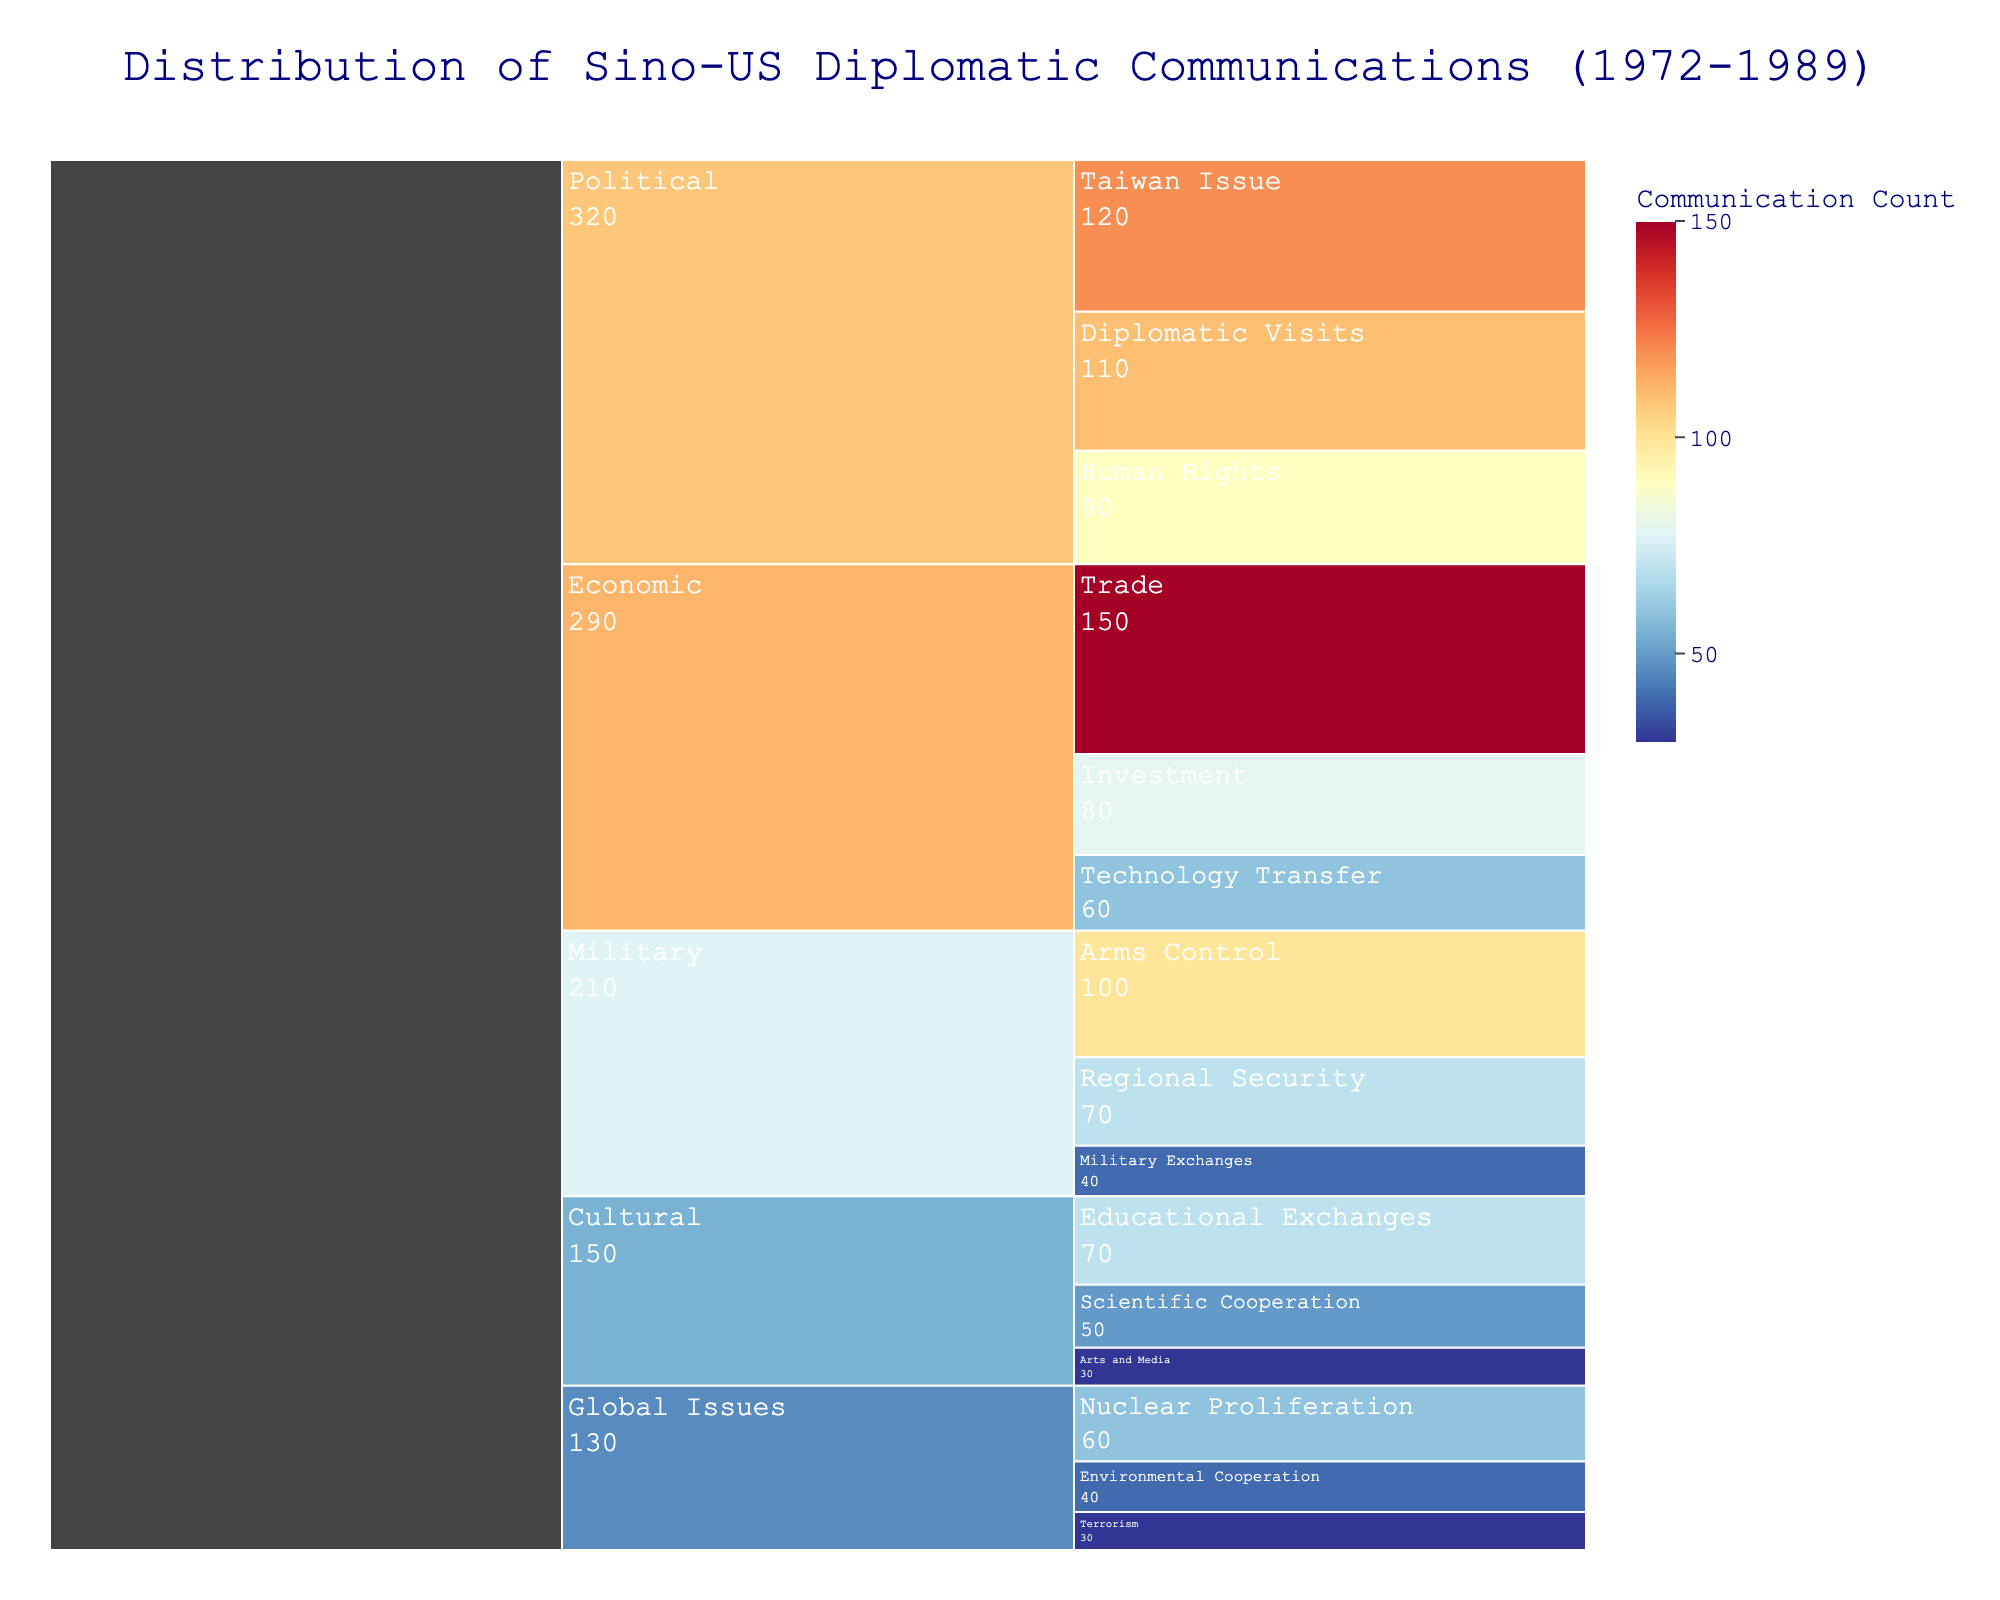What's the title of the chart? The title of a chart is typically located at the top and provides a description of the content. Here, the title is shown as "Distribution of Sino-US Diplomatic Communications (1972-1989)"
Answer: Distribution of Sino-US Diplomatic Communications (1972-1989) Which subtopic has the highest communication count within the 'Political' topic? To find this, identify the subtopics under 'Political' and check their counts. The subtopics are 'Human Rights', 'Taiwan Issue', and 'Diplomatic Visits' with counts 90, 120, and 110 respectively. 'Taiwan Issue' has the highest count of 120.
Answer: Taiwan Issue How many topics are represented in the chart? Topics are the top-level categories in the chart. They are 'Economic', 'Military', 'Political', 'Cultural', and 'Global Issues', making a total of five topics.
Answer: 5 Which topic has the least total count of diplomatic communications? Sum the counts for each topic: Economic (150+80+60=290), Military (100+70+40=210), Political (90+120+110=320), Cultural (70+50+30=150), Global Issues (40+30+60=130). 'Global Issues' has the least total count of 130.
Answer: Global Issues Compare the total count of 'Trade' and 'Taiwan Issue'. Which one is greater? 'Trade' has a count of 150, and 'Taiwan Issue' has a count of 120. Comparing these, 'Trade' has a greater count.
Answer: Trade is greater What is the combined communication count for 'Arms Control' and 'Regional Security' subtopics in the Military category? Sum the counts for 'Arms Control' and 'Regional Security': 100 + 70 = 170.
Answer: 170 How many subtopics are there under the 'Cultural' topic? The subtopics under 'Cultural' are 'Educational Exchanges', 'Scientific Cooperation', and 'Arts and Media'. This makes three subtopics.
Answer: 3 What is the average communication count of subtopics under the 'Global Issues' topic? Calculate the average by summing the counts and dividing by the number of subtopics: (40 + 30 + 60) / 3 = 130 / 3 = approximately 43.33
Answer: ~43.33 Which subtopic has the lowest communication count within the 'Cultural' topic? The subtopics under 'Cultural' are 'Educational Exchanges', 'Scientific Cooperation', and 'Arts and Media' with counts 70, 50, and 30 respectively. 'Arts and Media' has the lowest count of 30.
Answer: Arts and Media What percentage of the total communications is related to the 'Technology Transfer' subtopic? First, find the total count of all subtopics: 150+80+60+100+70+40+90+120+110+70+50+30+40+30+60 = 1100. Then, calculate the percentage: (60 / 1100) * 100 = approximately 5.45%.
Answer: ~5.45% 